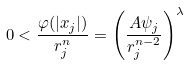<formula> <loc_0><loc_0><loc_500><loc_500>0 < \frac { \varphi ( | x _ { j } | ) } { r ^ { n } _ { j } } = \left ( \frac { A \psi _ { j } } { r ^ { n - 2 } _ { j } } \right ) ^ { \lambda }</formula> 